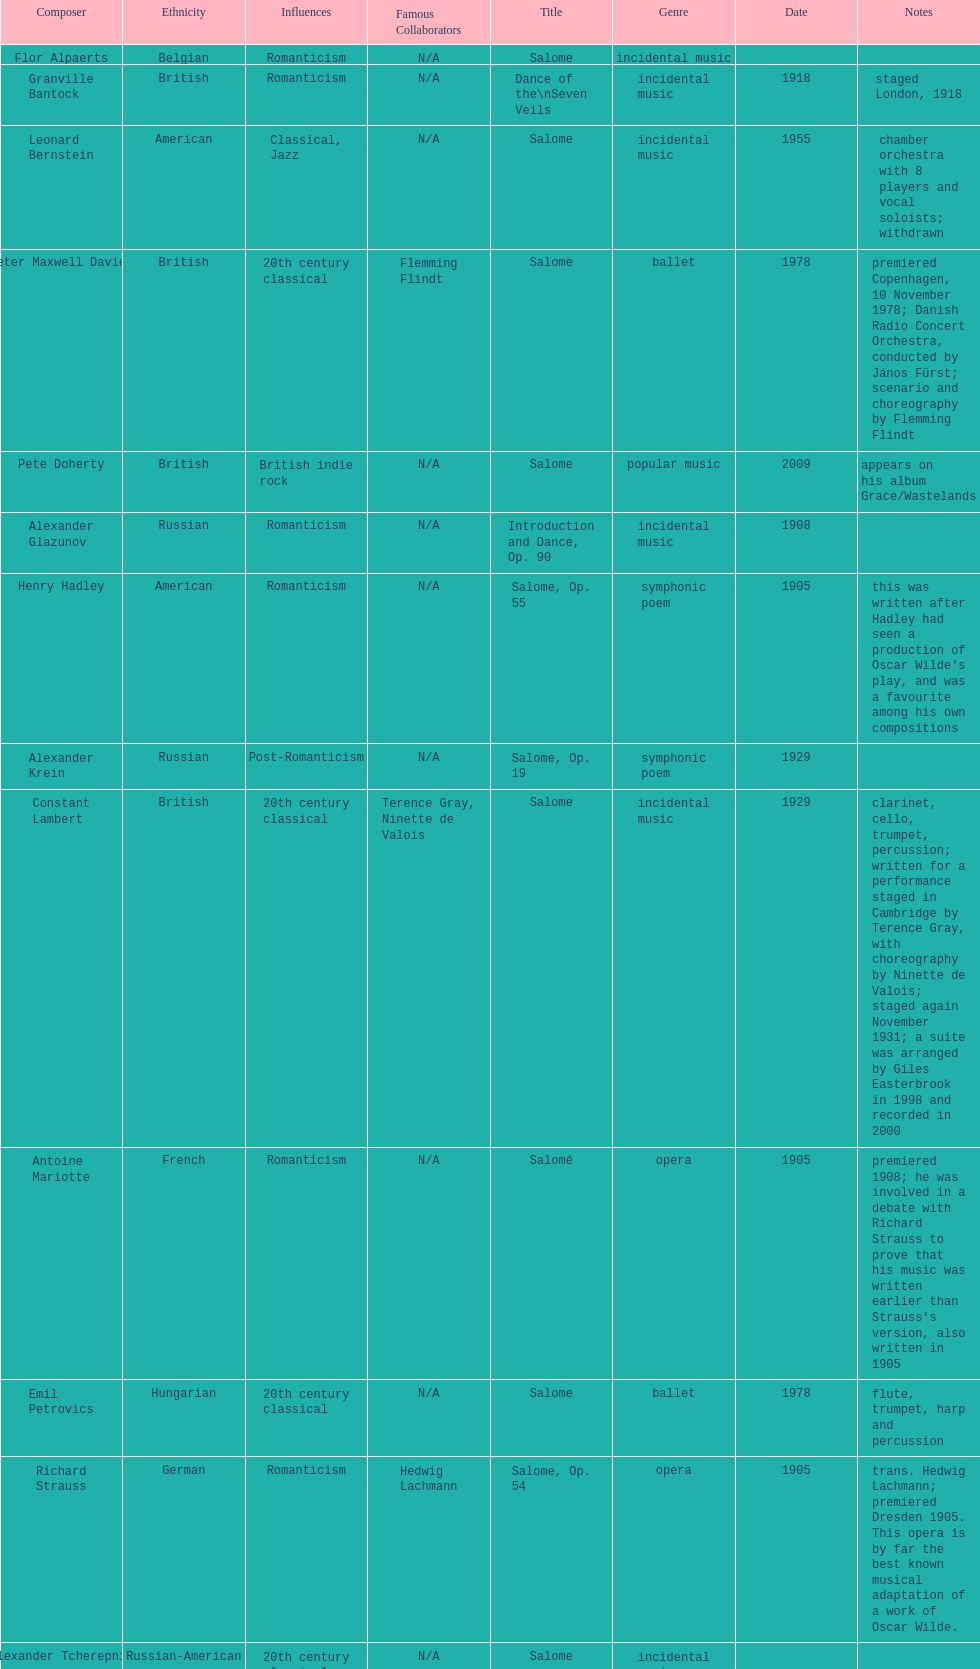Who is on top of the list? Flor Alpaerts. 